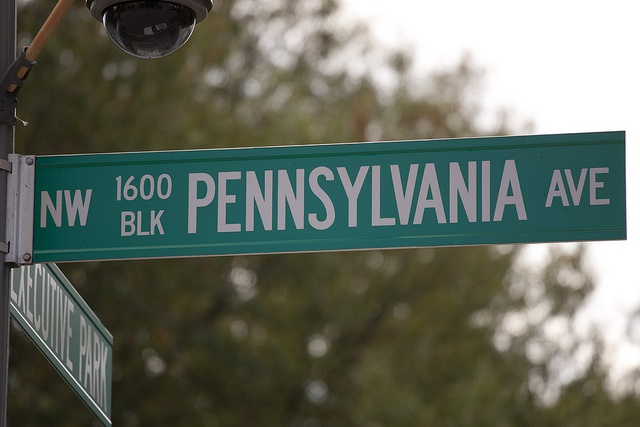Describe the objects in this image and their specific colors. I can see various objects in this image with different colors. 